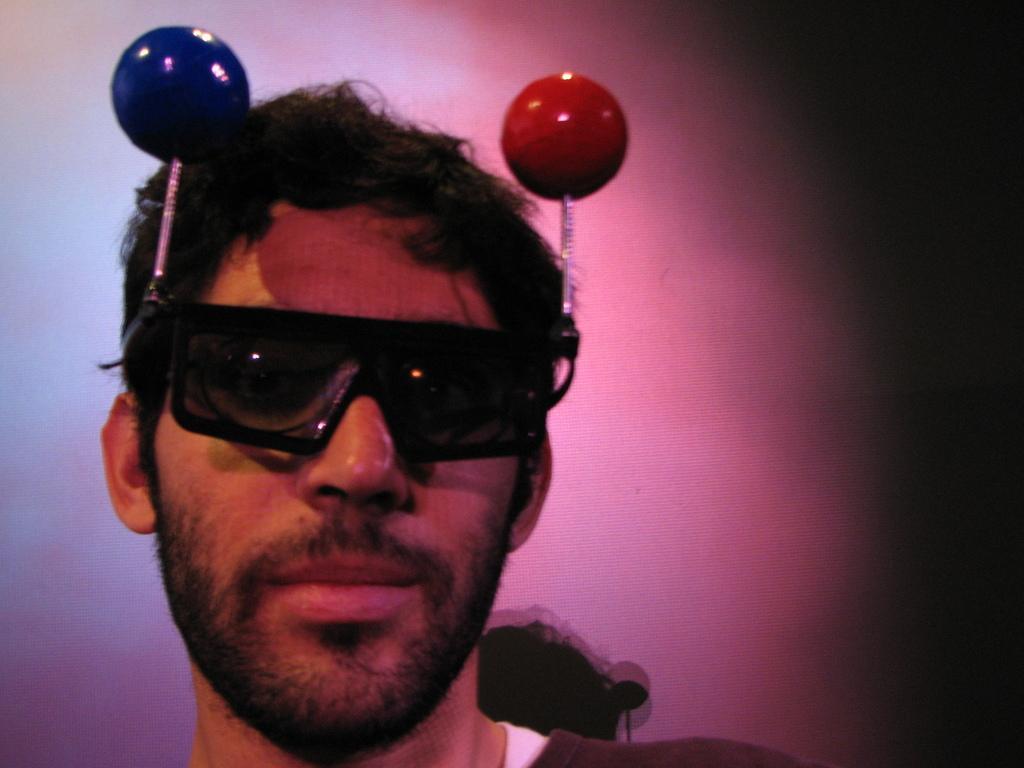Please provide a concise description of this image. As we can see in the image there is a wall and a person wearing goggles. 